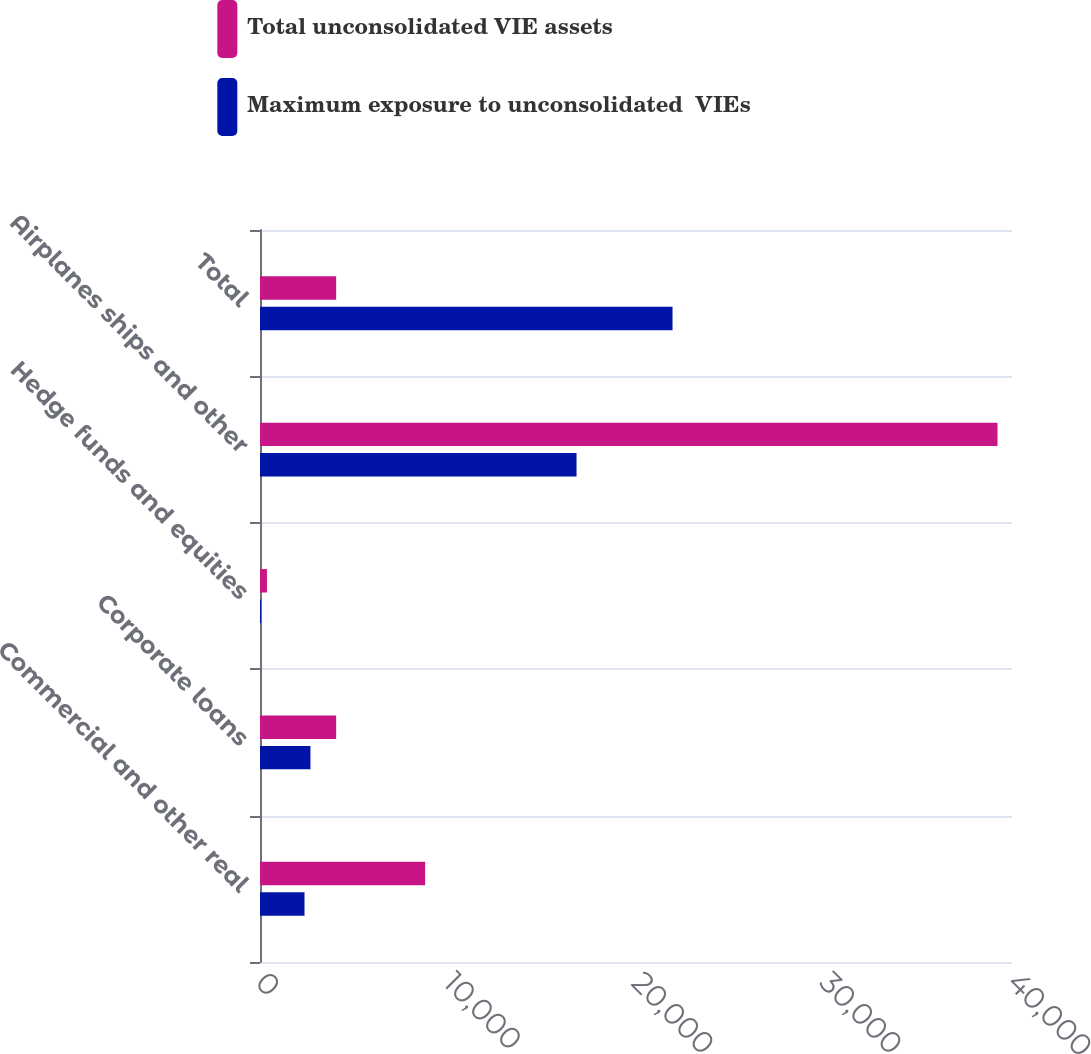Convert chart to OTSL. <chart><loc_0><loc_0><loc_500><loc_500><stacked_bar_chart><ecel><fcel>Commercial and other real<fcel>Corporate loans<fcel>Hedge funds and equities<fcel>Airplanes ships and other<fcel>Total<nl><fcel>Total unconsolidated VIE assets<fcel>8784<fcel>4051<fcel>370<fcel>39230<fcel>4051<nl><fcel>Maximum exposure to unconsolidated  VIEs<fcel>2368<fcel>2684<fcel>54<fcel>16837<fcel>21943<nl></chart> 